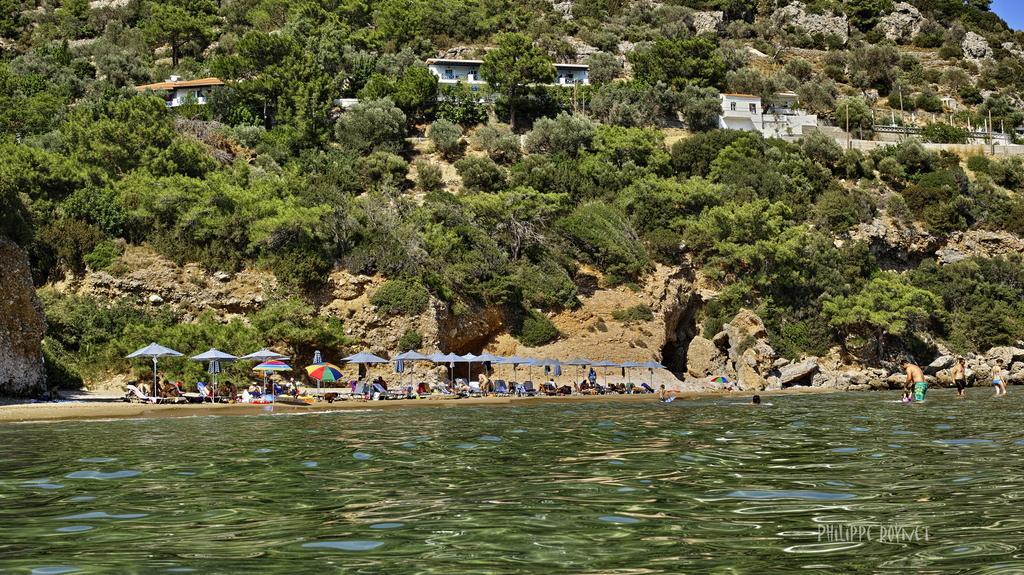Please provide a concise description of this image. At the bottom of the image there is water and we can see people in the water. There are parasols and we can see people. In the background there are trees and sheds. 